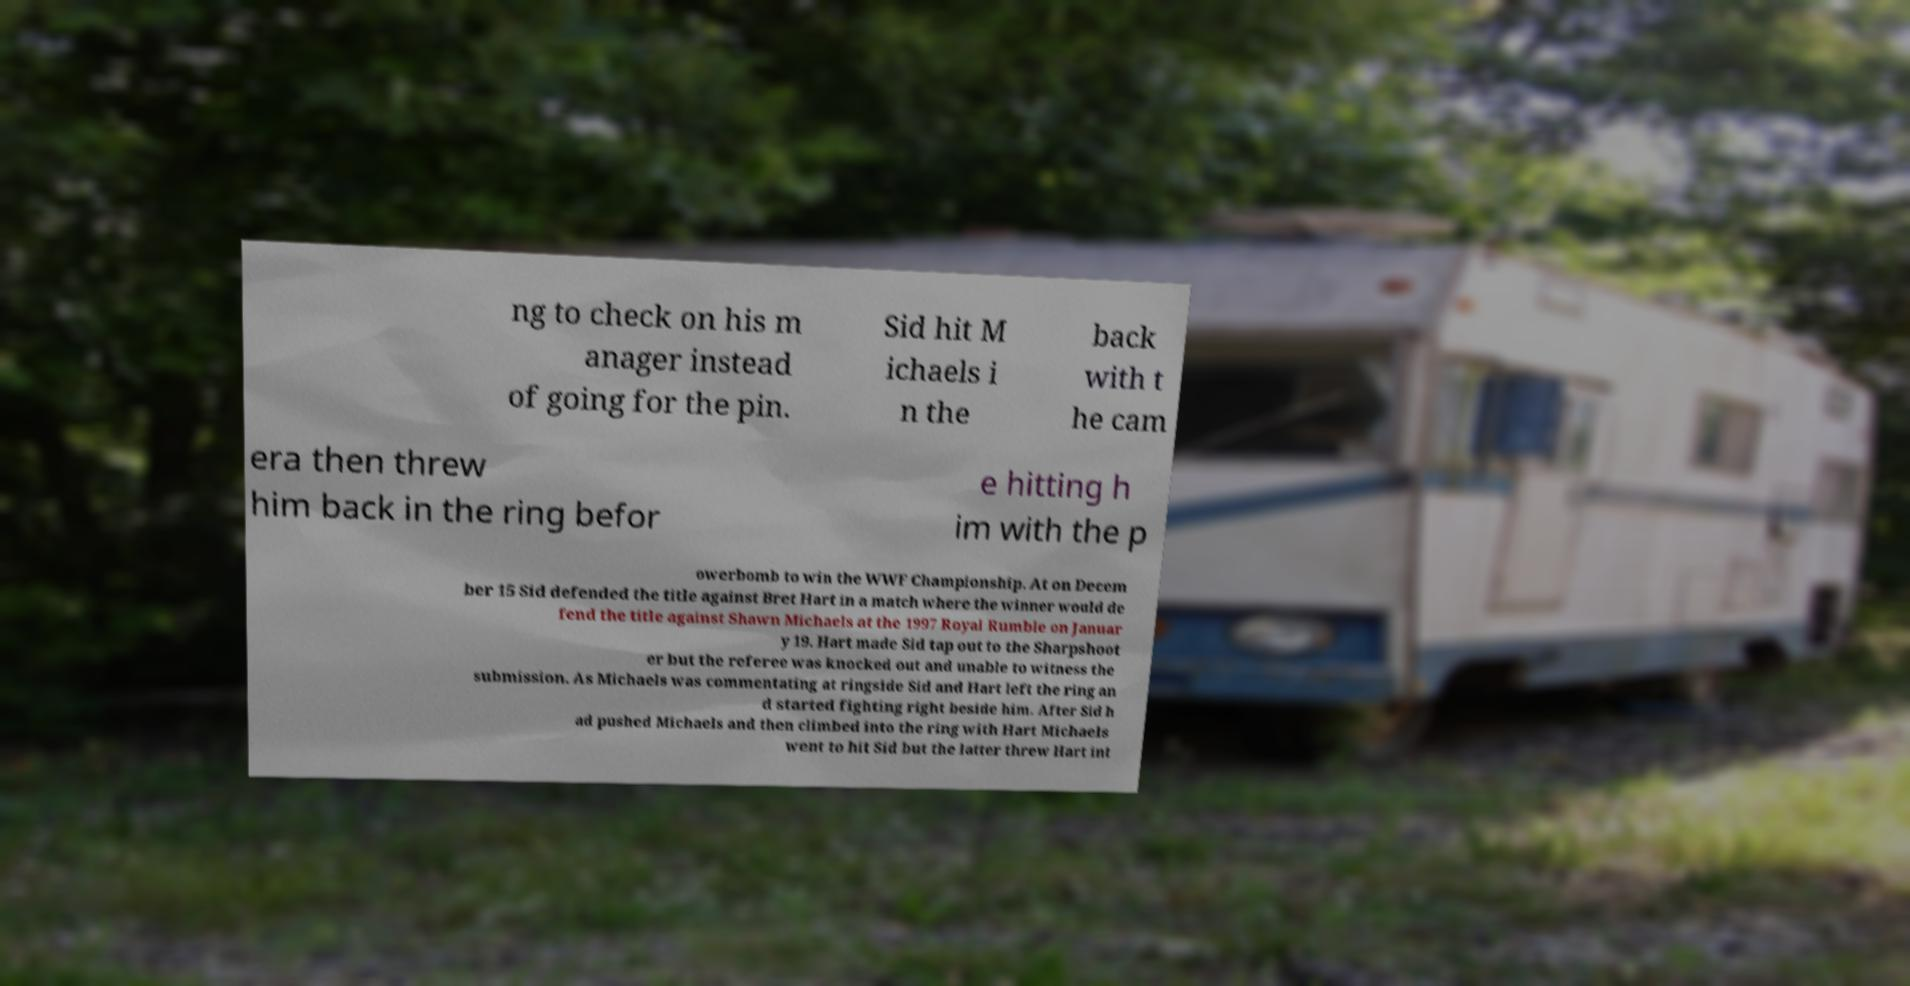Please identify and transcribe the text found in this image. ng to check on his m anager instead of going for the pin. Sid hit M ichaels i n the back with t he cam era then threw him back in the ring befor e hitting h im with the p owerbomb to win the WWF Championship. At on Decem ber 15 Sid defended the title against Bret Hart in a match where the winner would de fend the title against Shawn Michaels at the 1997 Royal Rumble on Januar y 19. Hart made Sid tap out to the Sharpshoot er but the referee was knocked out and unable to witness the submission. As Michaels was commentating at ringside Sid and Hart left the ring an d started fighting right beside him. After Sid h ad pushed Michaels and then climbed into the ring with Hart Michaels went to hit Sid but the latter threw Hart int 